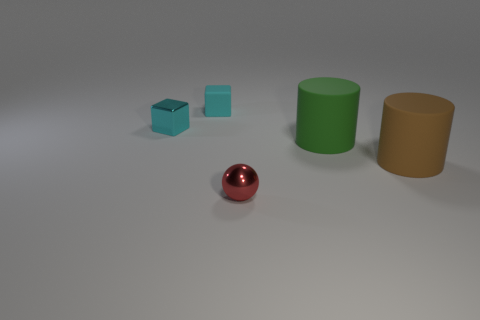Are there any other things of the same color as the matte block? Yes, the small and the large translucent cubes share the same color as the matte block, showcasing different shades of cyan with varying transparency levels. 